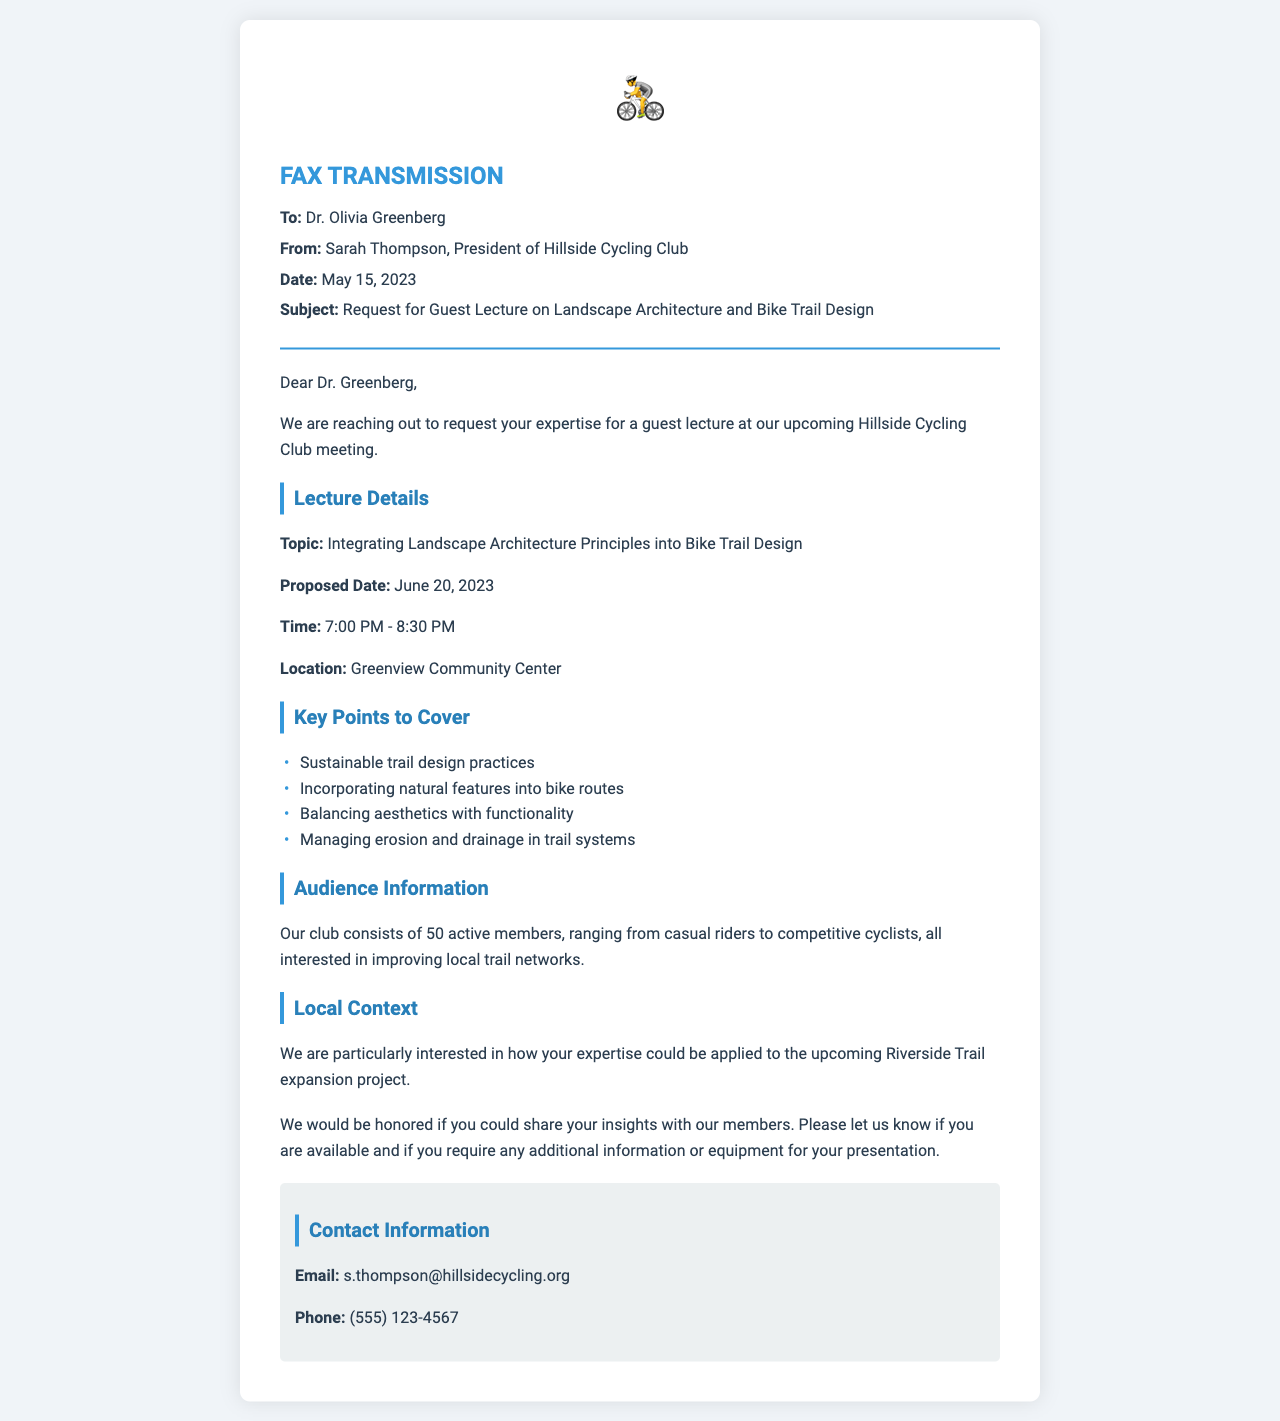What is the name of the person sending the fax? The sender's name is mentioned in the document, identifying Sarah Thompson as the President of the Hillside Cycling Club.
Answer: Sarah Thompson What is the proposed date for the guest lecture? The document specifies the proposed date for the lecture as June 20, 2023, which is clearly stated in the lecture details.
Answer: June 20, 2023 What is the topic of the lecture? The topic of the lecture is clearly stated in the document, outlining the focus on landscape architecture principles in bike trail design.
Answer: Integrating Landscape Architecture Principles into Bike Trail Design How long is the lecture scheduled to last? The duration is specified in the document; it notes the lecture will take place from 7:00 PM to 8:30 PM.
Answer: 1 hour 30 minutes How many active members are in the cycling club? The document provides an exact count of the active members in the cycling club.
Answer: 50 What location is mentioned for the guest lecture? The location for the guest lecture is identified in the document as the Greenview Community Center.
Answer: Greenview Community Center What is a key point to cover in the lecture regarding trail design? The document lists sustainable trail design practices as one of the key points to be addressed in the lecture.
Answer: Sustainable trail design practices Which project is highlighted in the local context section? The local context section explicitly mentions the Riverside Trail expansion project as the area of interest for applying expertise.
Answer: Riverside Trail expansion project What contact method is provided for further inquiries? The document provides an email address as a contact method, which is indicated for any further communication or inquiries.
Answer: s.thompson@hillsidecycling.org 